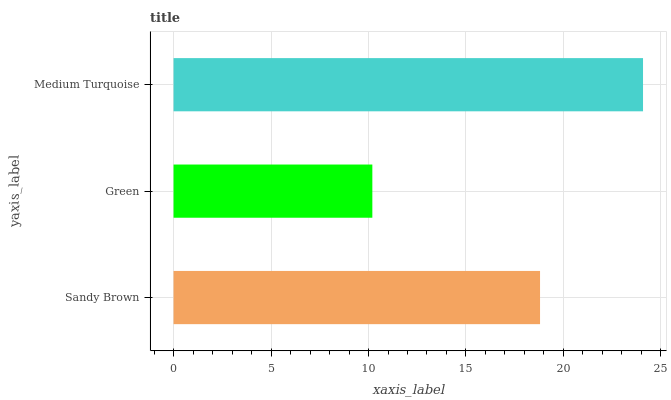Is Green the minimum?
Answer yes or no. Yes. Is Medium Turquoise the maximum?
Answer yes or no. Yes. Is Medium Turquoise the minimum?
Answer yes or no. No. Is Green the maximum?
Answer yes or no. No. Is Medium Turquoise greater than Green?
Answer yes or no. Yes. Is Green less than Medium Turquoise?
Answer yes or no. Yes. Is Green greater than Medium Turquoise?
Answer yes or no. No. Is Medium Turquoise less than Green?
Answer yes or no. No. Is Sandy Brown the high median?
Answer yes or no. Yes. Is Sandy Brown the low median?
Answer yes or no. Yes. Is Medium Turquoise the high median?
Answer yes or no. No. Is Green the low median?
Answer yes or no. No. 